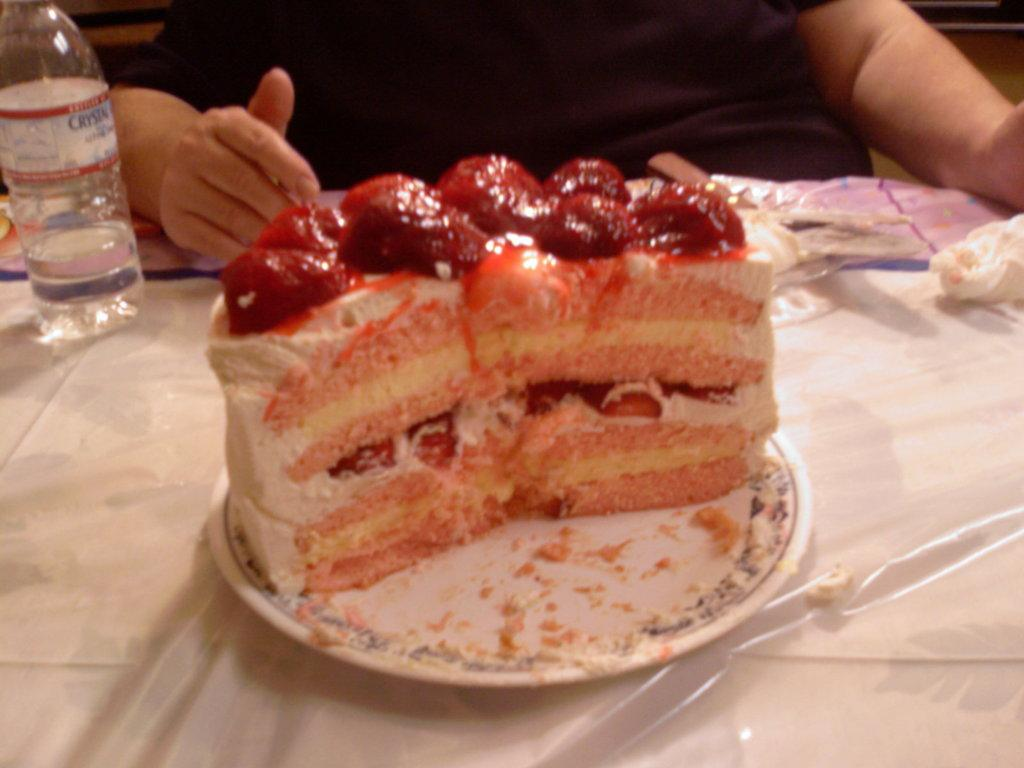What is on the plate that is visible in the image? There is food placed on a plate in the image. Where is the plate located in the image? The plate is on a table in the image. What else can be seen on the table in the image? There is a water bottle on the table in the image. What is the person in the image doing? The person is sitting in front of the table in the image. What is the person sitting on in the image? The person is sitting in a chair in the image. How many snails are crawling on the person's chair in the image? There are no snails visible in the image; the person is sitting in a chair without any snails present. 